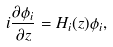Convert formula to latex. <formula><loc_0><loc_0><loc_500><loc_500>i \frac { \partial \phi _ { i } } { \partial z } = H _ { i } ( z ) \phi _ { i } ,</formula> 